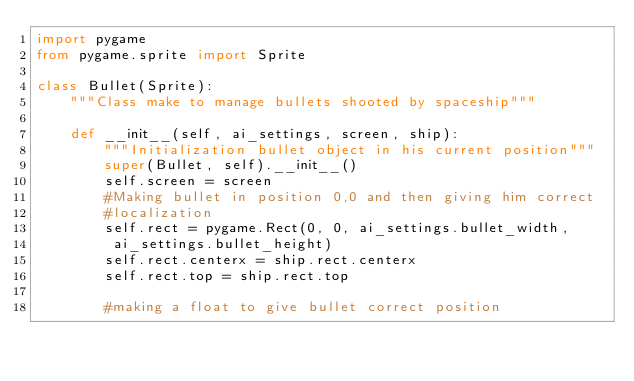<code> <loc_0><loc_0><loc_500><loc_500><_Python_>import pygame
from pygame.sprite import Sprite

class Bullet(Sprite):
	"""Class make to manage bullets shooted by spaceship"""
	
	def __init__(self, ai_settings, screen, ship):
		"""Initialization bullet object in his current position"""
		super(Bullet, self).__init__()
		self.screen = screen
		#Making bullet in position 0,0 and then giving him correct 
		#localization
		self.rect = pygame.Rect(0, 0, ai_settings.bullet_width,
		 ai_settings.bullet_height)
		self.rect.centerx = ship.rect.centerx
		self.rect.top = ship.rect.top

		#making a float to give bullet correct position</code> 